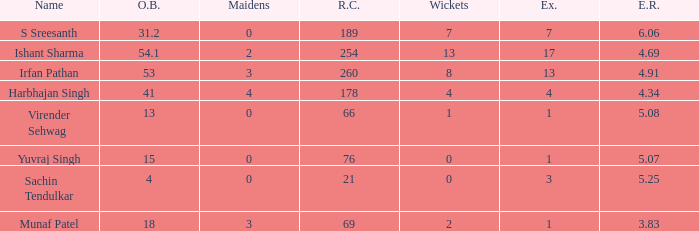Name the maaidens where overs bowled is 13 0.0. 